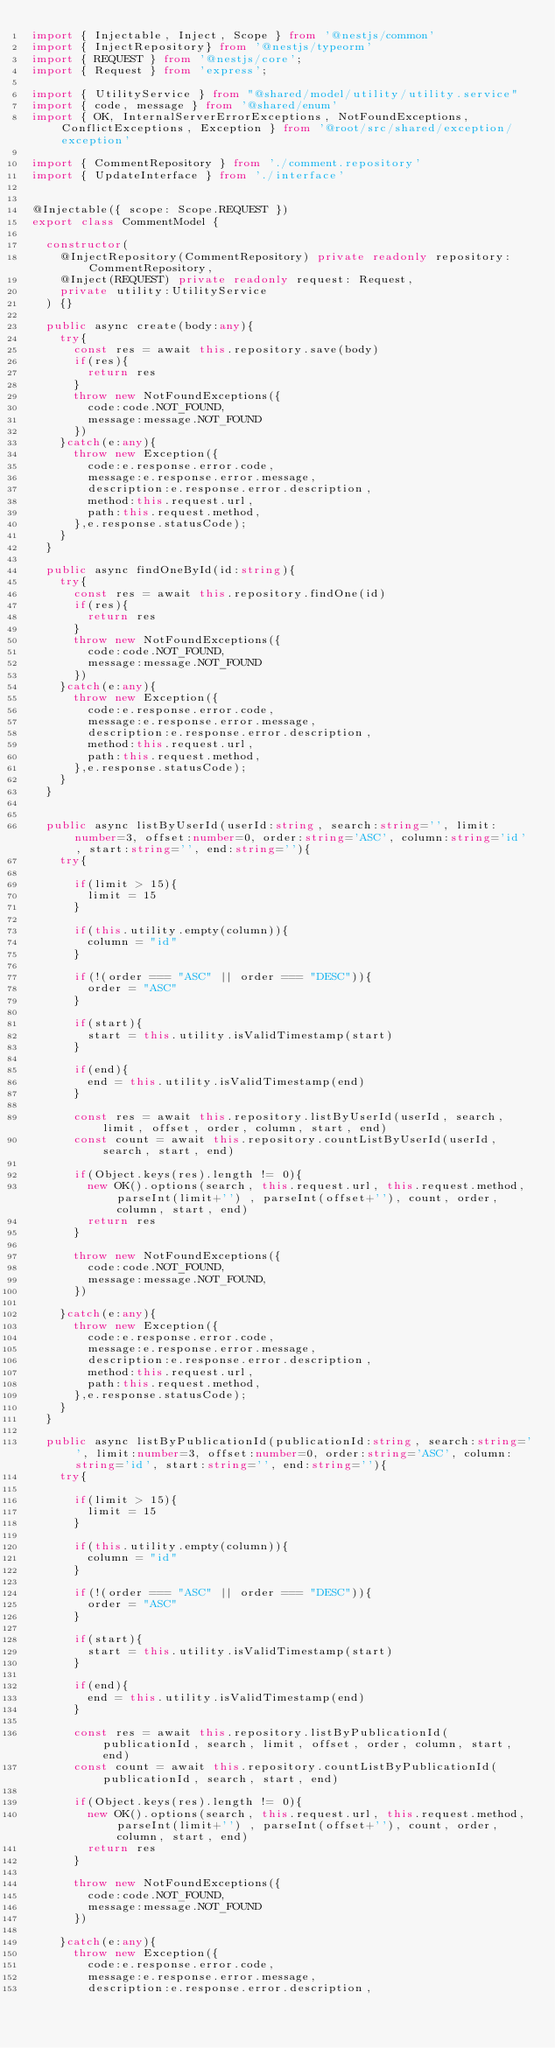<code> <loc_0><loc_0><loc_500><loc_500><_TypeScript_>import { Injectable, Inject, Scope } from '@nestjs/common'
import { InjectRepository} from '@nestjs/typeorm'
import { REQUEST } from '@nestjs/core';
import { Request } from 'express';

import { UtilityService } from "@shared/model/utility/utility.service"
import { code, message } from '@shared/enum'
import { OK, InternalServerErrorExceptions, NotFoundExceptions, ConflictExceptions, Exception } from '@root/src/shared/exception/exception'

import { CommentRepository } from './comment.repository'
import { UpdateInterface } from './interface'


@Injectable({ scope: Scope.REQUEST })
export class CommentModel {

  constructor(
    @InjectRepository(CommentRepository) private readonly repository: CommentRepository,
    @Inject(REQUEST) private readonly request: Request,
    private utility:UtilityService
  ) {}

  public async create(body:any){
    try{
      const res = await this.repository.save(body)
      if(res){
        return res
      }
      throw new NotFoundExceptions({
        code:code.NOT_FOUND,
        message:message.NOT_FOUND
      })
    }catch(e:any){
      throw new Exception({
        code:e.response.error.code,
        message:e.response.error.message,
        description:e.response.error.description,
        method:this.request.url,
        path:this.request.method,
      },e.response.statusCode);
    }
  }

  public async findOneById(id:string){
    try{
      const res = await this.repository.findOne(id)
      if(res){
        return res
      }
      throw new NotFoundExceptions({
        code:code.NOT_FOUND,
        message:message.NOT_FOUND
      })
    }catch(e:any){
      throw new Exception({
        code:e.response.error.code,
        message:e.response.error.message,
        description:e.response.error.description,
        method:this.request.url,
        path:this.request.method,
      },e.response.statusCode);
    }
  }


  public async listByUserId(userId:string, search:string='', limit:number=3, offset:number=0, order:string='ASC', column:string='id', start:string='', end:string=''){
    try{

      if(limit > 15){
        limit = 15
      }
    
      if(this.utility.empty(column)){
        column = "id"
      }

      if(!(order === "ASC" || order === "DESC")){
        order = "ASC"
      }

      if(start){
        start = this.utility.isValidTimestamp(start)
      }

      if(end){
        end = this.utility.isValidTimestamp(end)
      }
      
      const res = await this.repository.listByUserId(userId, search, limit, offset, order, column, start, end)
      const count = await this.repository.countListByUserId(userId, search, start, end)
 
      if(Object.keys(res).length != 0){
        new OK().options(search, this.request.url, this.request.method, parseInt(limit+'') , parseInt(offset+''), count, order, column, start, end)        
        return res
      }

      throw new NotFoundExceptions({
        code:code.NOT_FOUND,
        message:message.NOT_FOUND,
      })
      
    }catch(e:any){
      throw new Exception({
        code:e.response.error.code,
        message:e.response.error.message,
        description:e.response.error.description,
        method:this.request.url,
        path:this.request.method,
      },e.response.statusCode);
    }
  }

  public async listByPublicationId(publicationId:string, search:string='', limit:number=3, offset:number=0, order:string='ASC', column:string='id', start:string='', end:string=''){
    try{

      if(limit > 15){
        limit = 15
      }

      if(this.utility.empty(column)){
        column = "id"
      }

      if(!(order === "ASC" || order === "DESC")){
        order = "ASC"
      }

      if(start){
        start = this.utility.isValidTimestamp(start)
      }

      if(end){
        end = this.utility.isValidTimestamp(end)
      }

      const res = await this.repository.listByPublicationId(publicationId, search, limit, offset, order, column, start, end)
      const count = await this.repository.countListByPublicationId(publicationId, search, start, end)

      if(Object.keys(res).length != 0){
        new OK().options(search, this.request.url, this.request.method, parseInt(limit+'') , parseInt(offset+''), count, order, column, start, end)        
        return res
      }

      throw new NotFoundExceptions({
        code:code.NOT_FOUND,
        message:message.NOT_FOUND
      })

    }catch(e:any){
      throw new Exception({
        code:e.response.error.code,
        message:e.response.error.message,
        description:e.response.error.description,</code> 